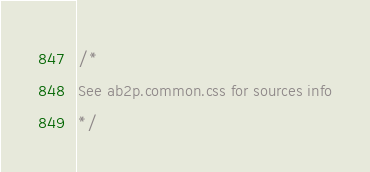Convert code to text. <code><loc_0><loc_0><loc_500><loc_500><_CSS_>/*
See ab2p.common.css for sources info
*/</code> 